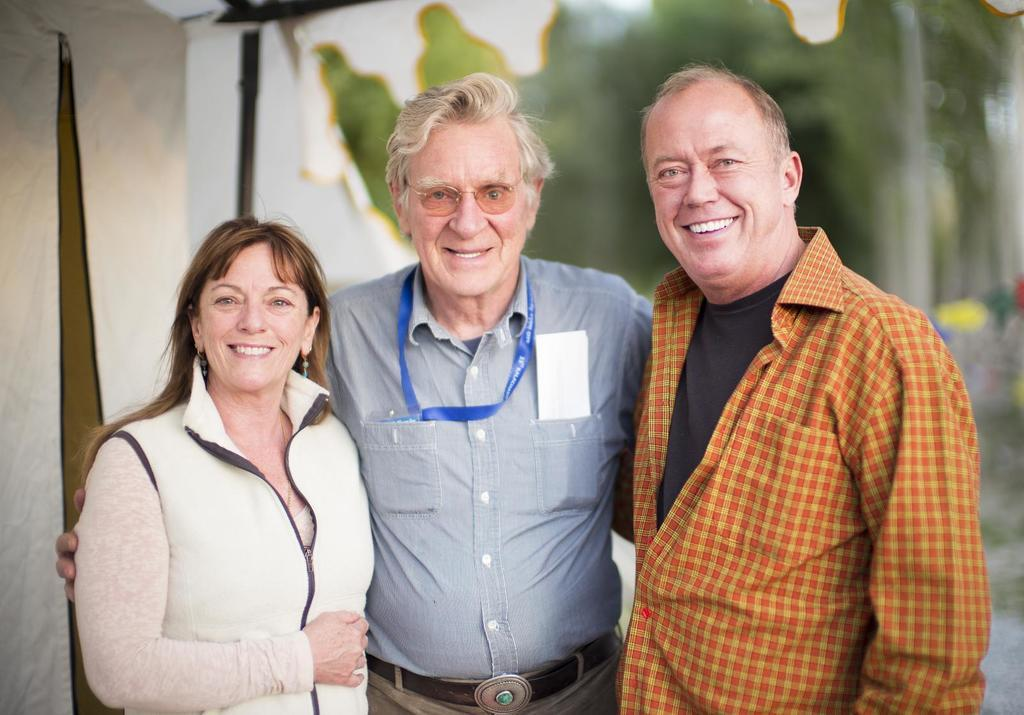How many people are in the image? There are three people in the image. What are the people doing in the image? The people are standing and smiling. What can be seen in the background of the image? There are trees and a tent in the background of the image. What type of boot can be seen in the image? There is no boot present in the image. Can you hear thunder in the image? The image is silent, and there is no indication of thunder or any sound. 